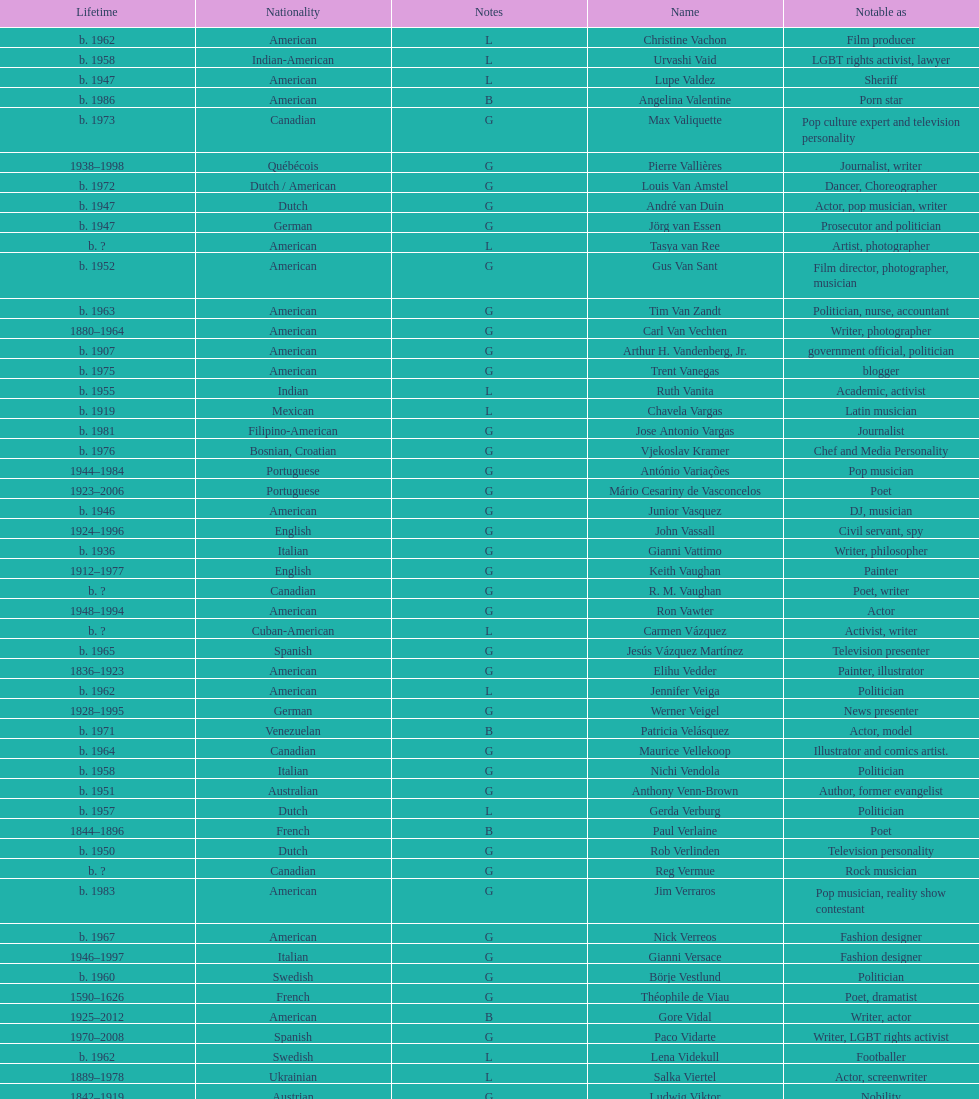Which nationality had the most notable poets? French. 